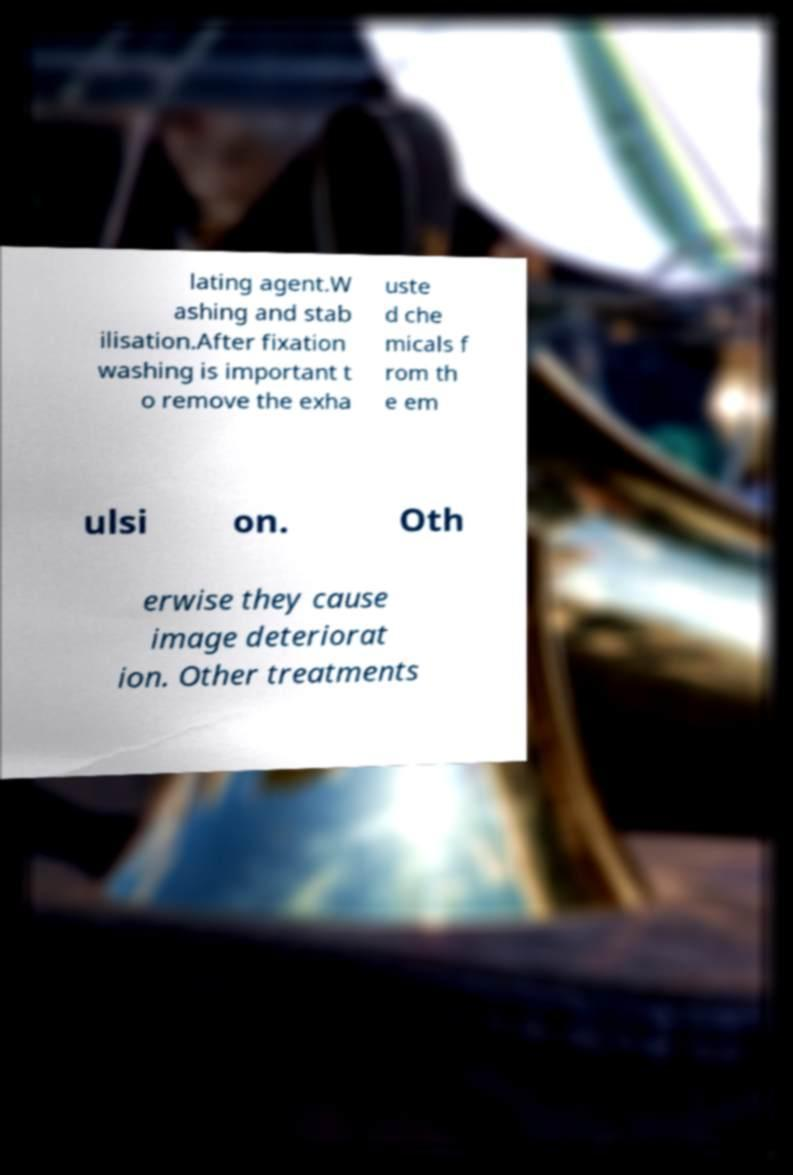Could you assist in decoding the text presented in this image and type it out clearly? lating agent.W ashing and stab ilisation.After fixation washing is important t o remove the exha uste d che micals f rom th e em ulsi on. Oth erwise they cause image deteriorat ion. Other treatments 